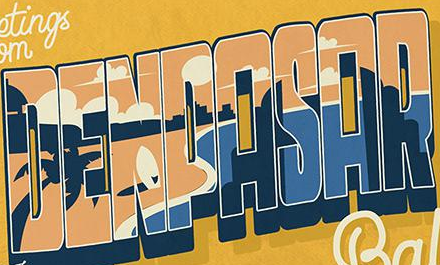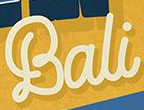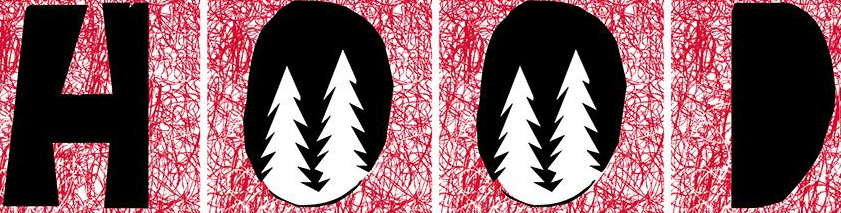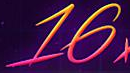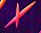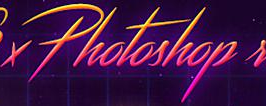What text appears in these images from left to right, separated by a semicolon? DENPASAR; Bali; HOOD; 16; ×; Photoshop 